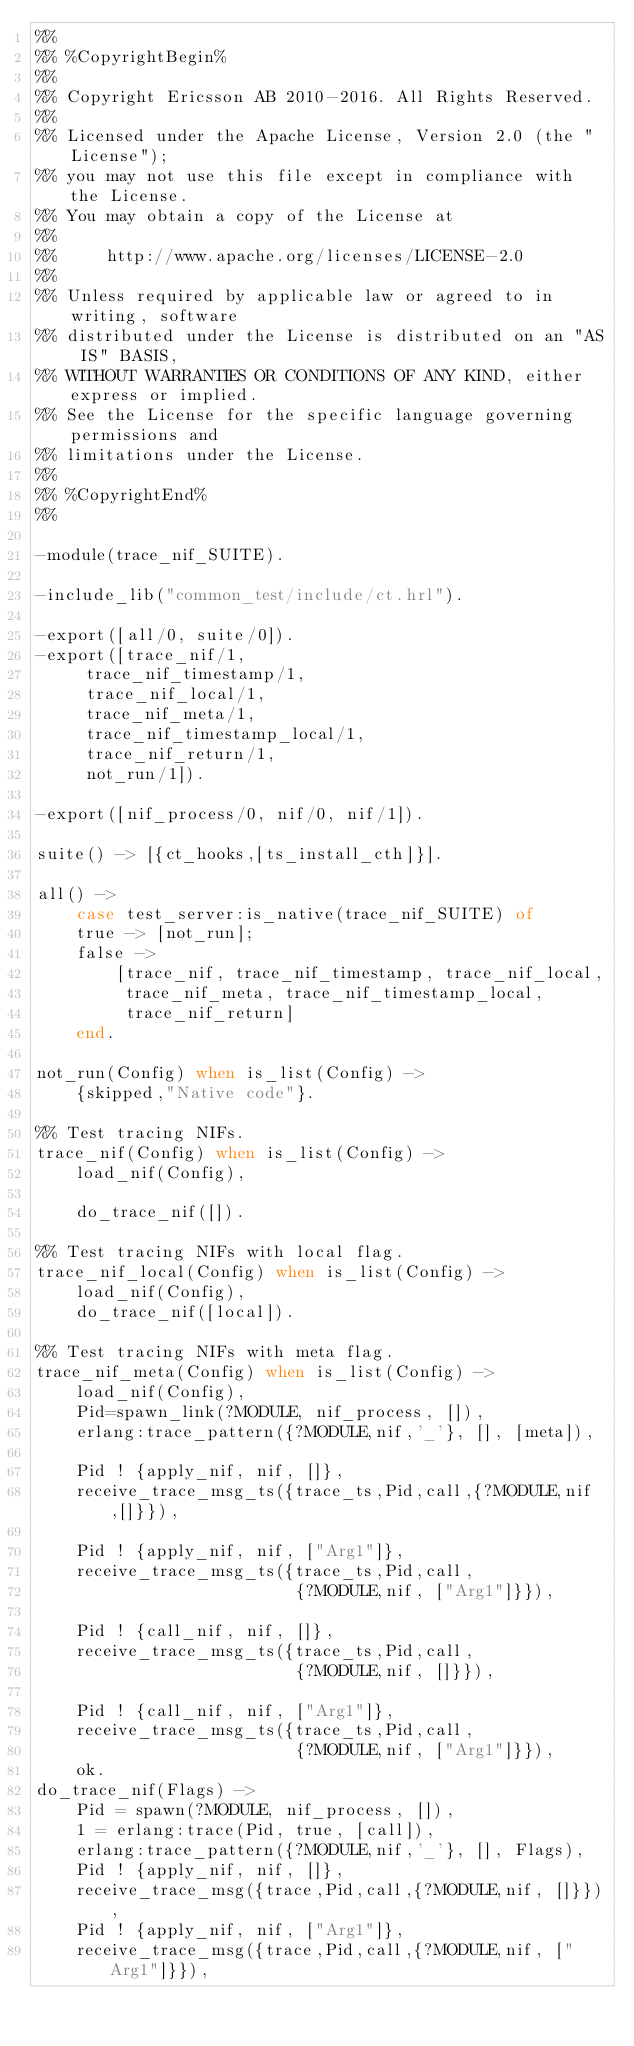Convert code to text. <code><loc_0><loc_0><loc_500><loc_500><_Erlang_>%%
%% %CopyrightBegin%
%% 
%% Copyright Ericsson AB 2010-2016. All Rights Reserved.
%% 
%% Licensed under the Apache License, Version 2.0 (the "License");
%% you may not use this file except in compliance with the License.
%% You may obtain a copy of the License at
%%
%%     http://www.apache.org/licenses/LICENSE-2.0
%%
%% Unless required by applicable law or agreed to in writing, software
%% distributed under the License is distributed on an "AS IS" BASIS,
%% WITHOUT WARRANTIES OR CONDITIONS OF ANY KIND, either express or implied.
%% See the License for the specific language governing permissions and
%% limitations under the License.
%% 
%% %CopyrightEnd%
%%

-module(trace_nif_SUITE).

-include_lib("common_test/include/ct.hrl").

-export([all/0, suite/0]).
-export([trace_nif/1,
	 trace_nif_timestamp/1,
	 trace_nif_local/1,
	 trace_nif_meta/1,
	 trace_nif_timestamp_local/1,
	 trace_nif_return/1,
	 not_run/1]).

-export([nif_process/0, nif/0, nif/1]).

suite() -> [{ct_hooks,[ts_install_cth]}].

all() -> 
    case test_server:is_native(trace_nif_SUITE) of
	true -> [not_run];
	false ->
	    [trace_nif, trace_nif_timestamp, trace_nif_local,
	     trace_nif_meta, trace_nif_timestamp_local,
	     trace_nif_return]
    end.

not_run(Config) when is_list(Config) -> 
    {skipped,"Native code"}.

%% Test tracing NIFs.
trace_nif(Config) when is_list(Config) ->
    load_nif(Config),

    do_trace_nif([]).

%% Test tracing NIFs with local flag.
trace_nif_local(Config) when is_list(Config) ->
    load_nif(Config),
    do_trace_nif([local]).

%% Test tracing NIFs with meta flag.
trace_nif_meta(Config) when is_list(Config) ->
    load_nif(Config),
    Pid=spawn_link(?MODULE, nif_process, []),
    erlang:trace_pattern({?MODULE,nif,'_'}, [], [meta]),

    Pid ! {apply_nif, nif, []},
    receive_trace_msg_ts({trace_ts,Pid,call,{?MODULE,nif,[]}}),

    Pid ! {apply_nif, nif, ["Arg1"]},
    receive_trace_msg_ts({trace_ts,Pid,call,
                          {?MODULE,nif, ["Arg1"]}}),

    Pid ! {call_nif, nif, []},
    receive_trace_msg_ts({trace_ts,Pid,call,
                          {?MODULE,nif, []}}),

    Pid ! {call_nif, nif, ["Arg1"]},
    receive_trace_msg_ts({trace_ts,Pid,call,
                          {?MODULE,nif, ["Arg1"]}}),
    ok.
do_trace_nif(Flags) ->
    Pid = spawn(?MODULE, nif_process, []),
    1 = erlang:trace(Pid, true, [call]),
    erlang:trace_pattern({?MODULE,nif,'_'}, [], Flags),
    Pid ! {apply_nif, nif, []},
    receive_trace_msg({trace,Pid,call,{?MODULE,nif, []}}),
    Pid ! {apply_nif, nif, ["Arg1"]},
    receive_trace_msg({trace,Pid,call,{?MODULE,nif, ["Arg1"]}}),
</code> 